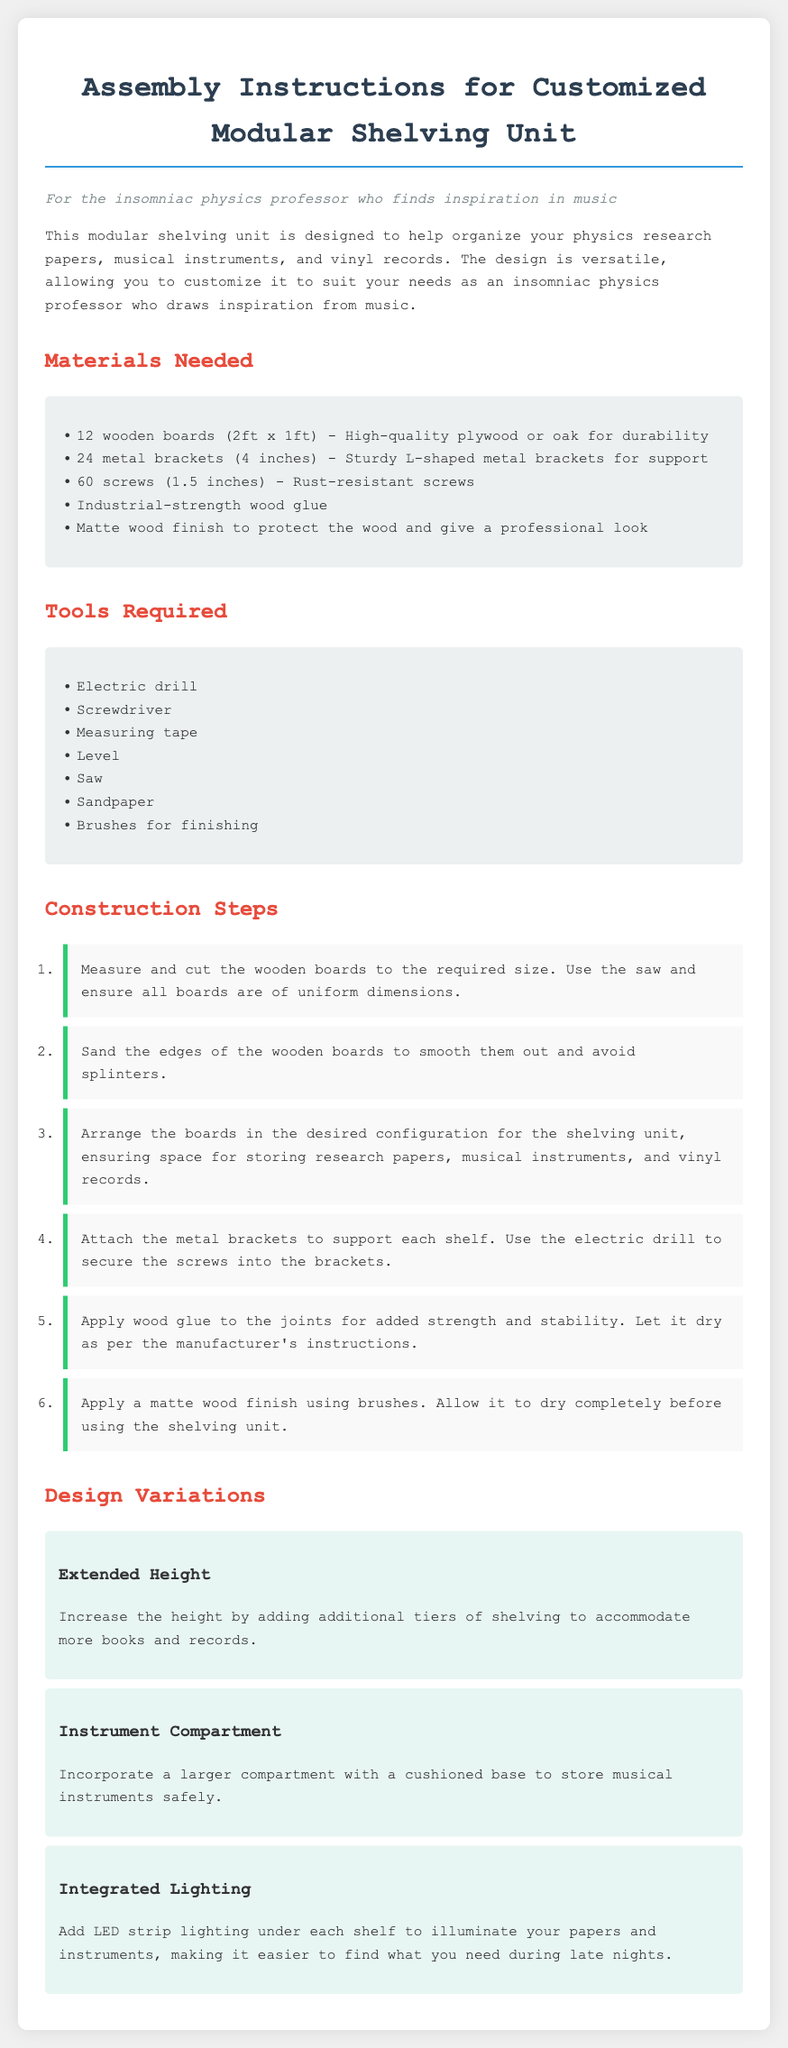What is the size of the wooden boards? The document specifies that the wooden boards are 2ft x 1ft.
Answer: 2ft x 1ft How many metal brackets are needed? The total number of metal brackets listed in the materials is 24.
Answer: 24 What tool is required for securing the screws? The instructions indicate the use of a screwdriver to secure the screws.
Answer: Screwdriver What step involves applying wood glue? The construction step that mentions applying wood glue is the fifth step.
Answer: Fifth step What is one design variation suggested for the shelving unit? One design variation suggested is "Integrated Lighting."
Answer: Integrated Lighting What finishing product is mentioned to protect the wood? The instructions recommend applying a matte wood finish.
Answer: Matte wood finish How many screws are required in total? The instructions specify a total of 60 screws needed for the assembly.
Answer: 60 Which tool is used to measure the wooden boards? The tool required for measuring is listed as measuring tape.
Answer: Measuring tape What is the purpose of sanding the edges of the wooden boards? The purpose of sanding is to smooth out the edges and avoid splinters.
Answer: Avoid splinters 